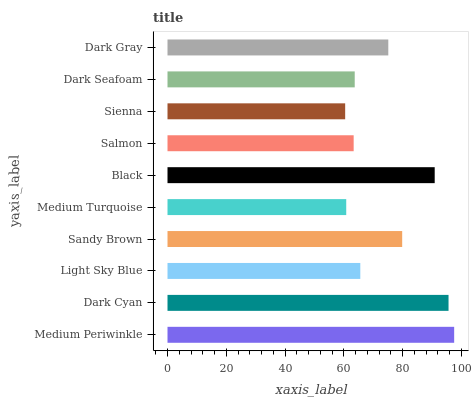Is Sienna the minimum?
Answer yes or no. Yes. Is Medium Periwinkle the maximum?
Answer yes or no. Yes. Is Dark Cyan the minimum?
Answer yes or no. No. Is Dark Cyan the maximum?
Answer yes or no. No. Is Medium Periwinkle greater than Dark Cyan?
Answer yes or no. Yes. Is Dark Cyan less than Medium Periwinkle?
Answer yes or no. Yes. Is Dark Cyan greater than Medium Periwinkle?
Answer yes or no. No. Is Medium Periwinkle less than Dark Cyan?
Answer yes or no. No. Is Dark Gray the high median?
Answer yes or no. Yes. Is Light Sky Blue the low median?
Answer yes or no. Yes. Is Dark Seafoam the high median?
Answer yes or no. No. Is Dark Cyan the low median?
Answer yes or no. No. 